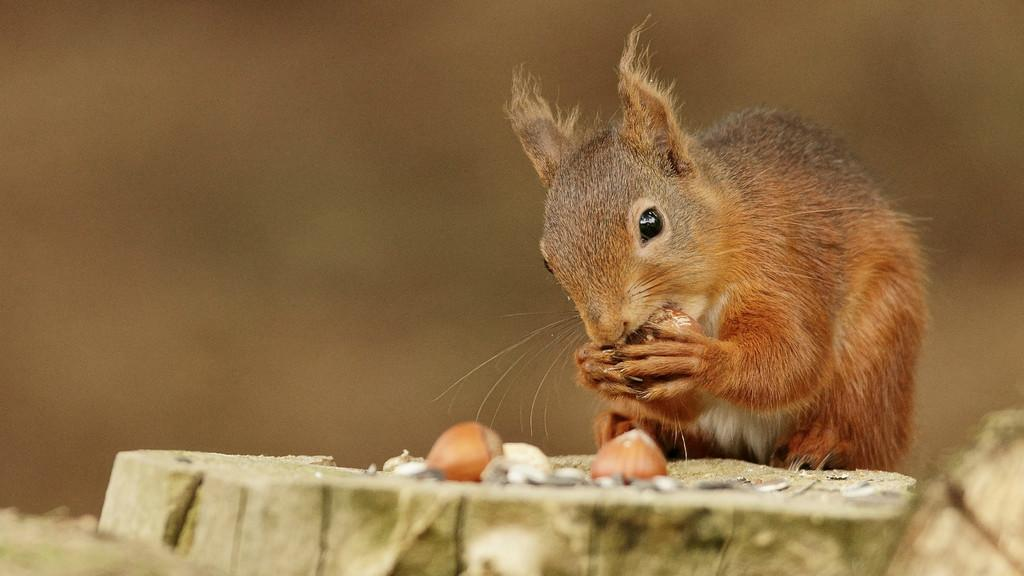What animal is located on the right side of the image? There is a fox squirrel on the right side of the image. What is the fox squirrel doing in the image? The fox squirrel is eating a food item. What type of material is visible at the bottom of the image? There is wood visible at the bottom of the image. What is the food item that the fox squirrel is eating? The food item is located at the bottom of the image. How would you describe the background of the image? The background of the image is blurry. What theory is the yak discussing with the fox squirrel in the image? There is no yak present in the image, and therefore no discussion or theory can be observed. 